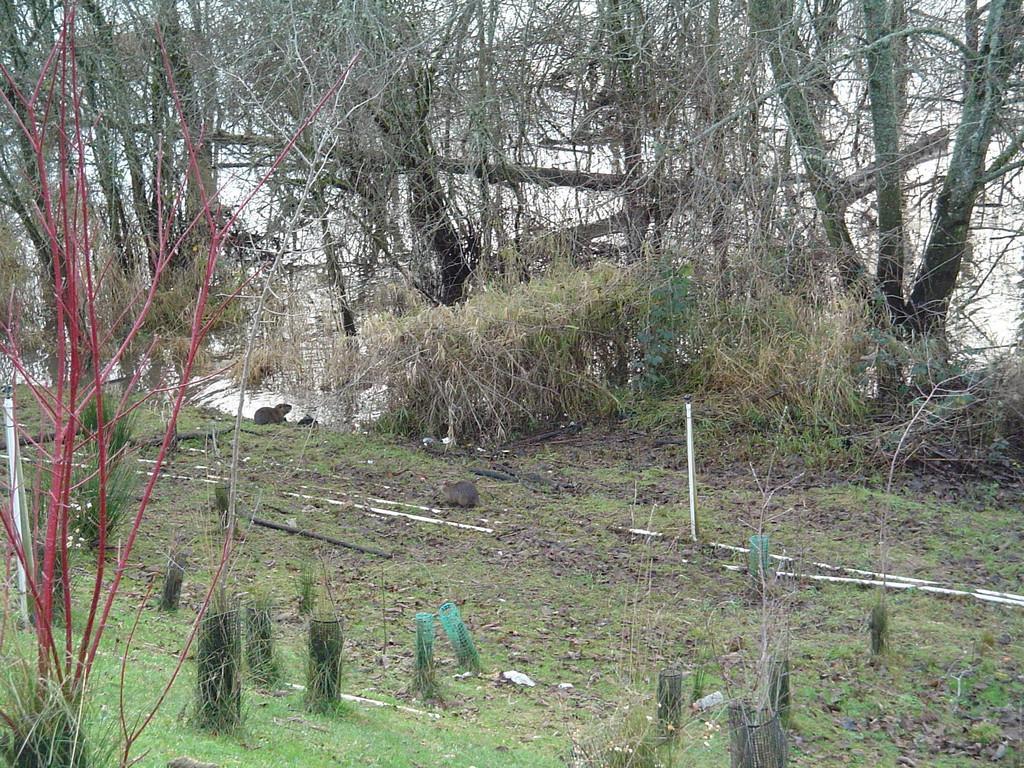Can you describe this image briefly? In this picture we can see few plants, trees and water. 